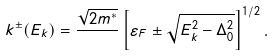<formula> <loc_0><loc_0><loc_500><loc_500>k ^ { \pm } ( E _ { k } ) = \frac { \sqrt { 2 m ^ { \ast } } } { } \left [ \varepsilon _ { F } \pm \sqrt { E _ { k } ^ { 2 } - \Delta _ { 0 } ^ { 2 } } \right ] ^ { 1 / 2 } .</formula> 